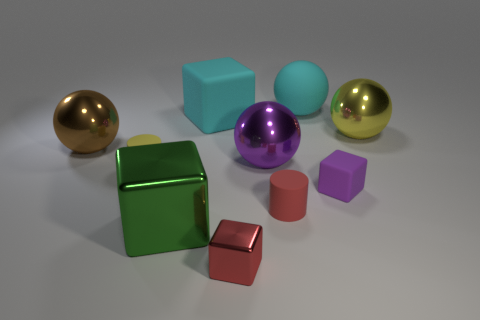Subtract all red blocks. How many blocks are left? 3 Subtract all brown cubes. Subtract all purple cylinders. How many cubes are left? 4 Subtract all balls. How many objects are left? 6 Add 9 brown metallic balls. How many brown metallic balls exist? 10 Subtract 0 cyan cylinders. How many objects are left? 10 Subtract all yellow rubber objects. Subtract all large purple balls. How many objects are left? 8 Add 5 big rubber objects. How many big rubber objects are left? 7 